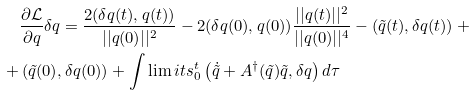<formula> <loc_0><loc_0><loc_500><loc_500>& \frac { \partial \mathcal { L } } { \partial q } \delta q = \frac { 2 ( \delta q ( t ) , q ( t ) ) } { | | q ( 0 ) | | ^ { 2 } } - 2 ( \delta q ( 0 ) , q ( 0 ) ) \frac { | | q ( t ) | | ^ { 2 } } { | | q ( 0 ) | | ^ { 4 } } - \left ( \tilde { q } ( t ) , \delta q ( t ) \right ) + \\ + & \left ( \tilde { q } ( 0 ) , \delta q ( 0 ) \right ) + \int \lim i t s _ { 0 } ^ { t } \left ( \dot { \tilde { q } } + A ^ { \dag } ( \tilde { q } ) \tilde { q } , \delta q \right ) d \tau</formula> 